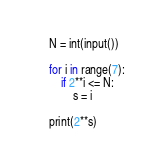Convert code to text. <code><loc_0><loc_0><loc_500><loc_500><_Python_>N = int(input())
 
for i in range(7):
    if 2**i <= N:
        s = i
        
print(2**s)
</code> 